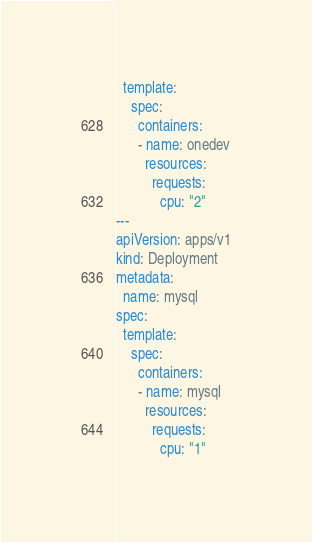Convert code to text. <code><loc_0><loc_0><loc_500><loc_500><_YAML_>  template:
    spec:
      containers:
      - name: onedev
        resources:
          requests: 
            cpu: "2"
---
apiVersion: apps/v1
kind: Deployment
metadata:
  name: mysql 
spec:
  template:
    spec:
      containers:
      - name: mysql
        resources:
          requests: 
            cpu: "1"
</code> 